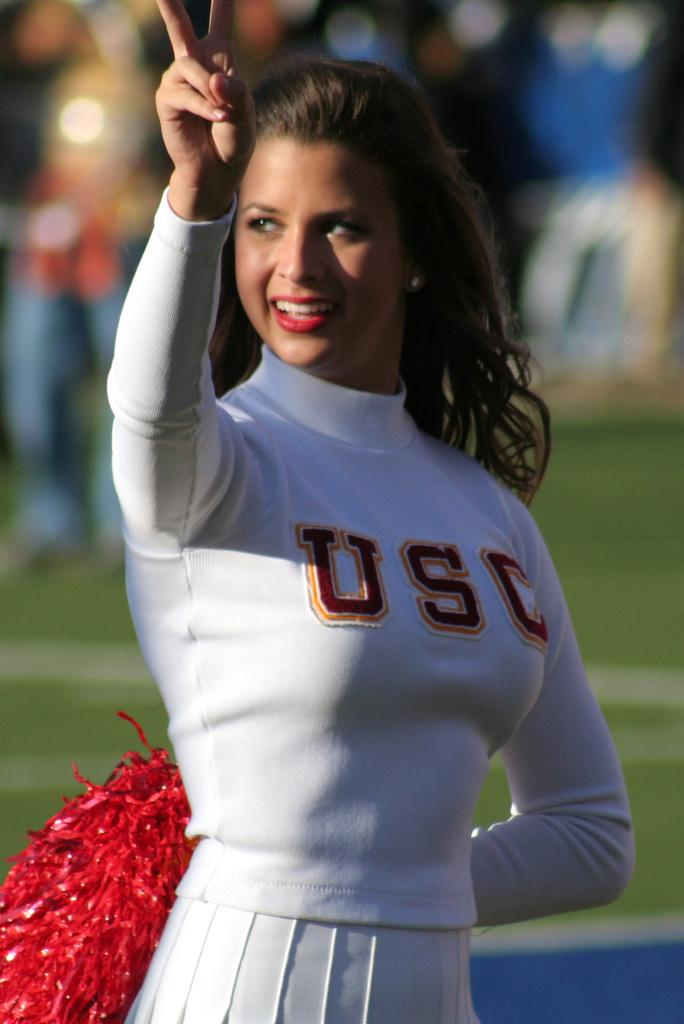<image>
Relay a brief, clear account of the picture shown. Cheerleading wearing a white top that says USC on it. 